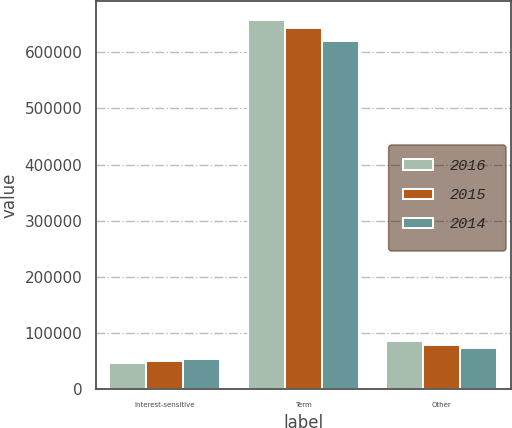<chart> <loc_0><loc_0><loc_500><loc_500><stacked_bar_chart><ecel><fcel>Interest-sensitive<fcel>Term<fcel>Other<nl><fcel>2016<fcel>47358<fcel>657797<fcel>86527<nl><fcel>2015<fcel>50808<fcel>642599<fcel>78801<nl><fcel>2014<fcel>54490<fcel>619782<fcel>73870<nl></chart> 